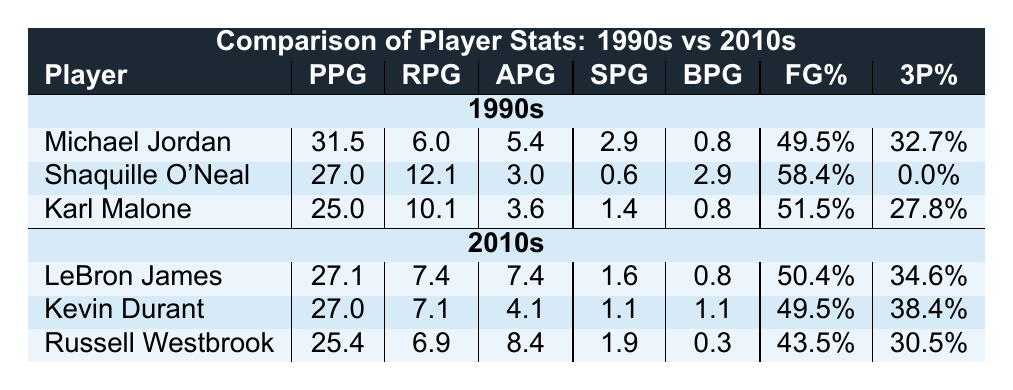What is Michael Jordan's points per game in the 1990s? Referring to the table, Michael Jordan's points per game (PPG) is listed as 31.5.
Answer: 31.5 Who had the highest rebounds per game in the 1990s? Looking at the rebounds per game (RPG) column for the 1990s, Shaquille O'Neal has the highest with 12.1 rebounds per game.
Answer: Shaquille O'Neal What is the field goal percentage of LeBron James? Referencing the field goal percentage (FG%) column for the 2010s, LeBron James has a field goal percentage of 50.4%.
Answer: 50.4% Which player had the highest assists per game in the 2010s? Examining the assists per game (APG) column for the 2010s, LeBron James had the highest assists with 7.4 per game.
Answer: LeBron James What is the average points per game for players in the 1990s? To find the average PPG for the 1990s: (31.5 + 27.0 + 25.0) = 83.5, and there are three players, so the average is 83.5 / 3 = 27.83.
Answer: 27.83 Does Karl Malone have a higher three-point percentage than Russell Westbrook? Checking the three-point percentage (3P%) column, Karl Malone's percentage is 27.8% while Russell Westbrook's is 30.5%. Since 27.8% is less than 30.5%, the statement is false.
Answer: No Which decade has a player with a higher field goal percentage, the 1990s or the 2010s? In the 1990s, Shaquille O'Neal has the highest FG% at 58.4%. In the 2010s, Kevin Durant has the highest at 49.5%. Since 58.4% is greater than 49.5%, the 1990s had a player with a higher FG%.
Answer: 1990s Compare the average steals per game for both decades. For the 1990s: (2.9 + 0.6 + 1.4) = 4.9, average is 4.9 / 3 = 1.63. For the 2010s: (1.6 + 1.1 + 1.9) = 4.6, average is 4.6 / 3 = 1.53. The average for the 1990s is higher than the 2010s.
Answer: 1990s Who had a better three-point shooting percentage, Kevin Durant or Michael Jordan? Kevin Durant's three-point percentage is 38.4%, while Michael Jordan's is 32.7%. Since 38.4% is greater than 32.7%, Durant had a better three-point percentage.
Answer: Kevin Durant 